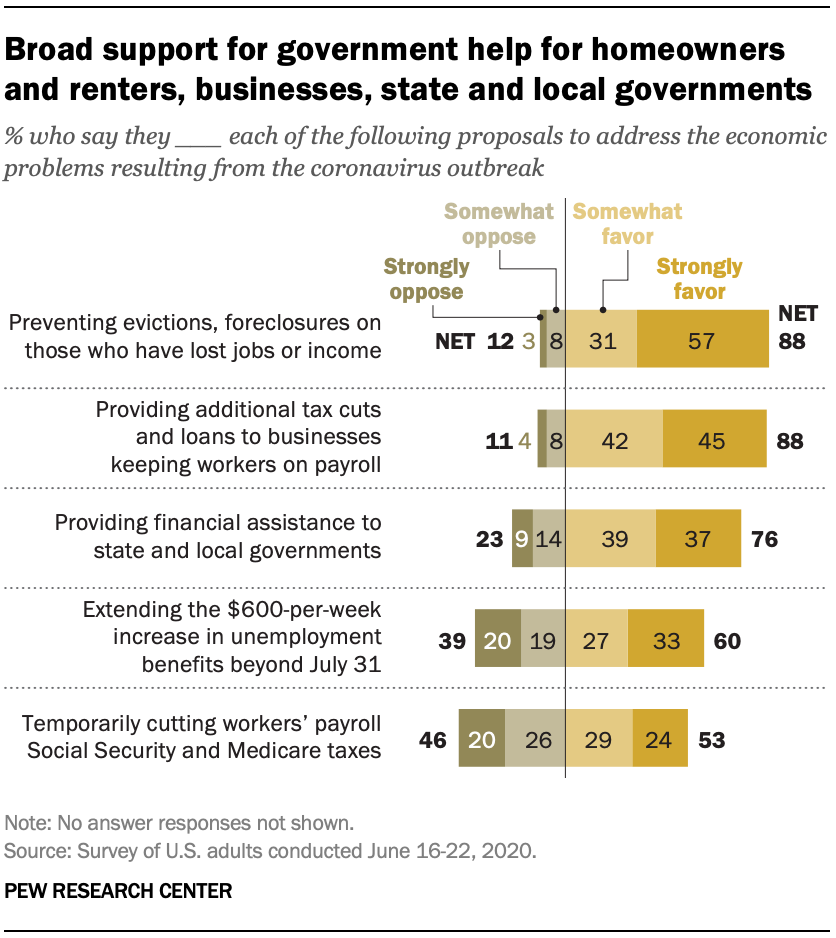Specify some key components in this picture. The median value of the gray bars is 14. The graph uses four colored bars. 